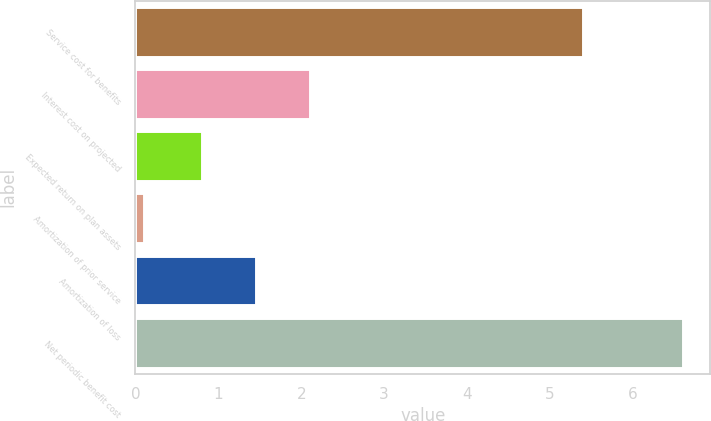Convert chart. <chart><loc_0><loc_0><loc_500><loc_500><bar_chart><fcel>Service cost for benefits<fcel>Interest cost on projected<fcel>Expected return on plan assets<fcel>Amortization of prior service<fcel>Amortization of loss<fcel>Net periodic benefit cost<nl><fcel>5.4<fcel>2.1<fcel>0.8<fcel>0.1<fcel>1.45<fcel>6.6<nl></chart> 